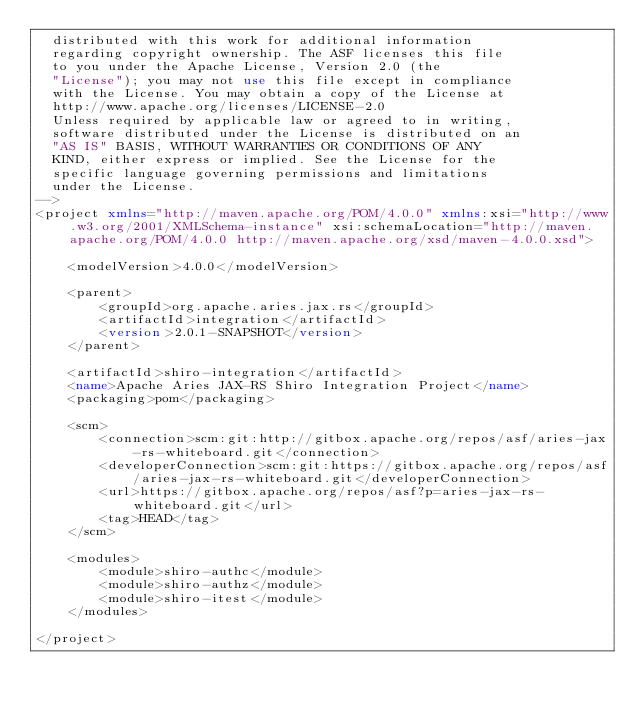<code> <loc_0><loc_0><loc_500><loc_500><_XML_>  distributed with this work for additional information
  regarding copyright ownership. The ASF licenses this file
  to you under the Apache License, Version 2.0 (the
  "License"); you may not use this file except in compliance
  with the License. You may obtain a copy of the License at
  http://www.apache.org/licenses/LICENSE-2.0
  Unless required by applicable law or agreed to in writing,
  software distributed under the License is distributed on an
  "AS IS" BASIS, WITHOUT WARRANTIES OR CONDITIONS OF ANY
  KIND, either express or implied. See the License for the
  specific language governing permissions and limitations
  under the License.
-->
<project xmlns="http://maven.apache.org/POM/4.0.0" xmlns:xsi="http://www.w3.org/2001/XMLSchema-instance" xsi:schemaLocation="http://maven.apache.org/POM/4.0.0 http://maven.apache.org/xsd/maven-4.0.0.xsd">

    <modelVersion>4.0.0</modelVersion>

    <parent>
        <groupId>org.apache.aries.jax.rs</groupId>
        <artifactId>integration</artifactId>
        <version>2.0.1-SNAPSHOT</version>
    </parent>

    <artifactId>shiro-integration</artifactId>
    <name>Apache Aries JAX-RS Shiro Integration Project</name>
    <packaging>pom</packaging>

    <scm>
        <connection>scm:git:http://gitbox.apache.org/repos/asf/aries-jax-rs-whiteboard.git</connection>
        <developerConnection>scm:git:https://gitbox.apache.org/repos/asf/aries-jax-rs-whiteboard.git</developerConnection>
        <url>https://gitbox.apache.org/repos/asf?p=aries-jax-rs-whiteboard.git</url>
        <tag>HEAD</tag>
    </scm>

    <modules>
        <module>shiro-authc</module>
        <module>shiro-authz</module>
        <module>shiro-itest</module>
    </modules>

</project></code> 